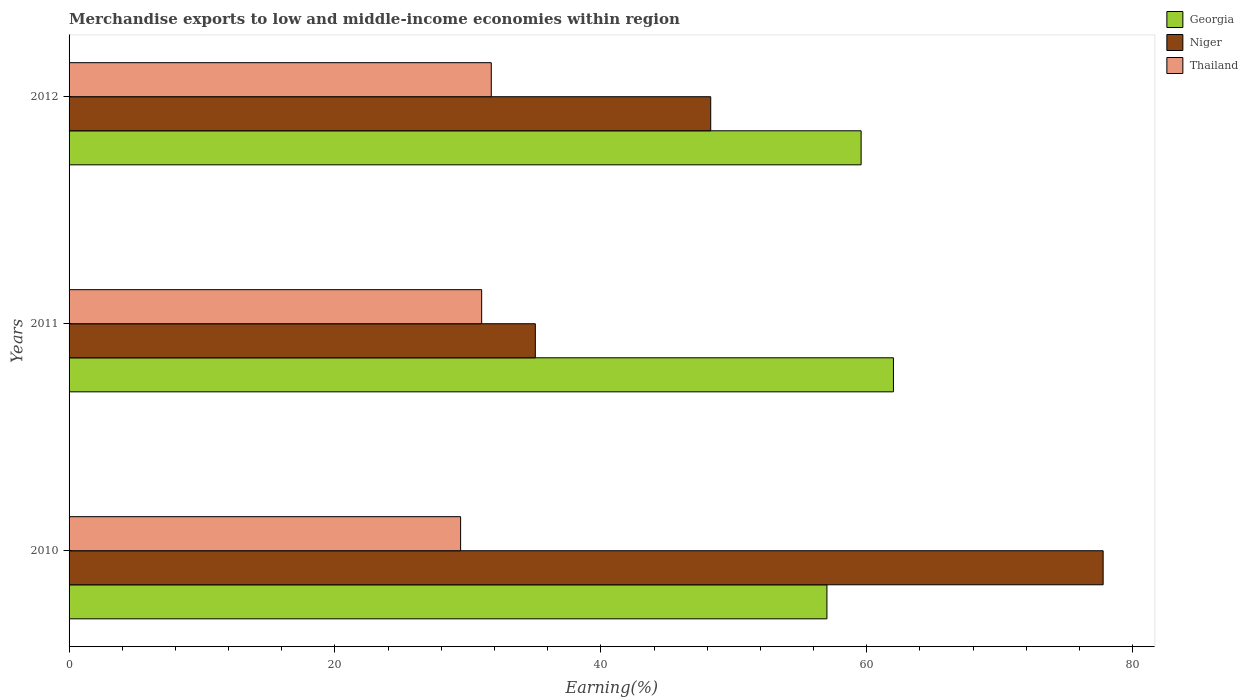Are the number of bars on each tick of the Y-axis equal?
Offer a very short reply. Yes. How many bars are there on the 2nd tick from the bottom?
Your answer should be compact. 3. What is the percentage of amount earned from merchandise exports in Thailand in 2012?
Keep it short and to the point. 31.76. Across all years, what is the maximum percentage of amount earned from merchandise exports in Niger?
Keep it short and to the point. 77.78. Across all years, what is the minimum percentage of amount earned from merchandise exports in Niger?
Provide a succinct answer. 35.07. In which year was the percentage of amount earned from merchandise exports in Thailand maximum?
Provide a succinct answer. 2012. In which year was the percentage of amount earned from merchandise exports in Georgia minimum?
Offer a very short reply. 2010. What is the total percentage of amount earned from merchandise exports in Niger in the graph?
Provide a short and direct response. 161.1. What is the difference between the percentage of amount earned from merchandise exports in Georgia in 2010 and that in 2011?
Your response must be concise. -5. What is the difference between the percentage of amount earned from merchandise exports in Georgia in 2011 and the percentage of amount earned from merchandise exports in Niger in 2012?
Provide a succinct answer. 13.74. What is the average percentage of amount earned from merchandise exports in Georgia per year?
Provide a succinct answer. 59.53. In the year 2011, what is the difference between the percentage of amount earned from merchandise exports in Georgia and percentage of amount earned from merchandise exports in Niger?
Provide a succinct answer. 26.93. What is the ratio of the percentage of amount earned from merchandise exports in Niger in 2010 to that in 2011?
Make the answer very short. 2.22. Is the percentage of amount earned from merchandise exports in Thailand in 2010 less than that in 2011?
Keep it short and to the point. Yes. What is the difference between the highest and the second highest percentage of amount earned from merchandise exports in Thailand?
Ensure brevity in your answer.  0.72. What is the difference between the highest and the lowest percentage of amount earned from merchandise exports in Niger?
Give a very brief answer. 42.71. In how many years, is the percentage of amount earned from merchandise exports in Thailand greater than the average percentage of amount earned from merchandise exports in Thailand taken over all years?
Give a very brief answer. 2. Is the sum of the percentage of amount earned from merchandise exports in Thailand in 2011 and 2012 greater than the maximum percentage of amount earned from merchandise exports in Georgia across all years?
Provide a succinct answer. Yes. What does the 2nd bar from the top in 2011 represents?
Your answer should be very brief. Niger. What does the 1st bar from the bottom in 2010 represents?
Your response must be concise. Georgia. Is it the case that in every year, the sum of the percentage of amount earned from merchandise exports in Niger and percentage of amount earned from merchandise exports in Georgia is greater than the percentage of amount earned from merchandise exports in Thailand?
Your response must be concise. Yes. How many bars are there?
Offer a terse response. 9. How many years are there in the graph?
Provide a succinct answer. 3. What is the difference between two consecutive major ticks on the X-axis?
Provide a short and direct response. 20. Are the values on the major ticks of X-axis written in scientific E-notation?
Offer a very short reply. No. How many legend labels are there?
Provide a short and direct response. 3. What is the title of the graph?
Ensure brevity in your answer.  Merchandise exports to low and middle-income economies within region. What is the label or title of the X-axis?
Keep it short and to the point. Earning(%). What is the label or title of the Y-axis?
Provide a short and direct response. Years. What is the Earning(%) in Georgia in 2010?
Make the answer very short. 57. What is the Earning(%) in Niger in 2010?
Provide a short and direct response. 77.78. What is the Earning(%) in Thailand in 2010?
Offer a very short reply. 29.45. What is the Earning(%) in Georgia in 2011?
Your answer should be compact. 62. What is the Earning(%) in Niger in 2011?
Offer a terse response. 35.07. What is the Earning(%) of Thailand in 2011?
Keep it short and to the point. 31.03. What is the Earning(%) of Georgia in 2012?
Make the answer very short. 59.57. What is the Earning(%) in Niger in 2012?
Your response must be concise. 48.26. What is the Earning(%) in Thailand in 2012?
Provide a short and direct response. 31.76. Across all years, what is the maximum Earning(%) of Georgia?
Keep it short and to the point. 62. Across all years, what is the maximum Earning(%) of Niger?
Provide a succinct answer. 77.78. Across all years, what is the maximum Earning(%) in Thailand?
Provide a succinct answer. 31.76. Across all years, what is the minimum Earning(%) in Georgia?
Your answer should be very brief. 57. Across all years, what is the minimum Earning(%) in Niger?
Provide a short and direct response. 35.07. Across all years, what is the minimum Earning(%) of Thailand?
Provide a succinct answer. 29.45. What is the total Earning(%) of Georgia in the graph?
Provide a short and direct response. 178.58. What is the total Earning(%) in Niger in the graph?
Provide a short and direct response. 161.1. What is the total Earning(%) in Thailand in the graph?
Your response must be concise. 92.24. What is the difference between the Earning(%) in Georgia in 2010 and that in 2011?
Keep it short and to the point. -5. What is the difference between the Earning(%) in Niger in 2010 and that in 2011?
Offer a very short reply. 42.71. What is the difference between the Earning(%) in Thailand in 2010 and that in 2011?
Keep it short and to the point. -1.58. What is the difference between the Earning(%) in Georgia in 2010 and that in 2012?
Give a very brief answer. -2.57. What is the difference between the Earning(%) in Niger in 2010 and that in 2012?
Offer a terse response. 29.52. What is the difference between the Earning(%) of Thailand in 2010 and that in 2012?
Offer a very short reply. -2.31. What is the difference between the Earning(%) in Georgia in 2011 and that in 2012?
Give a very brief answer. 2.43. What is the difference between the Earning(%) of Niger in 2011 and that in 2012?
Your response must be concise. -13.19. What is the difference between the Earning(%) of Thailand in 2011 and that in 2012?
Your response must be concise. -0.72. What is the difference between the Earning(%) of Georgia in 2010 and the Earning(%) of Niger in 2011?
Offer a very short reply. 21.93. What is the difference between the Earning(%) of Georgia in 2010 and the Earning(%) of Thailand in 2011?
Your answer should be very brief. 25.97. What is the difference between the Earning(%) in Niger in 2010 and the Earning(%) in Thailand in 2011?
Keep it short and to the point. 46.74. What is the difference between the Earning(%) in Georgia in 2010 and the Earning(%) in Niger in 2012?
Keep it short and to the point. 8.74. What is the difference between the Earning(%) of Georgia in 2010 and the Earning(%) of Thailand in 2012?
Offer a terse response. 25.25. What is the difference between the Earning(%) of Niger in 2010 and the Earning(%) of Thailand in 2012?
Your answer should be very brief. 46.02. What is the difference between the Earning(%) of Georgia in 2011 and the Earning(%) of Niger in 2012?
Ensure brevity in your answer.  13.74. What is the difference between the Earning(%) of Georgia in 2011 and the Earning(%) of Thailand in 2012?
Keep it short and to the point. 30.25. What is the difference between the Earning(%) of Niger in 2011 and the Earning(%) of Thailand in 2012?
Make the answer very short. 3.31. What is the average Earning(%) in Georgia per year?
Provide a short and direct response. 59.53. What is the average Earning(%) in Niger per year?
Give a very brief answer. 53.7. What is the average Earning(%) in Thailand per year?
Your response must be concise. 30.75. In the year 2010, what is the difference between the Earning(%) in Georgia and Earning(%) in Niger?
Give a very brief answer. -20.77. In the year 2010, what is the difference between the Earning(%) of Georgia and Earning(%) of Thailand?
Make the answer very short. 27.55. In the year 2010, what is the difference between the Earning(%) in Niger and Earning(%) in Thailand?
Your answer should be compact. 48.33. In the year 2011, what is the difference between the Earning(%) in Georgia and Earning(%) in Niger?
Make the answer very short. 26.93. In the year 2011, what is the difference between the Earning(%) of Georgia and Earning(%) of Thailand?
Your answer should be very brief. 30.97. In the year 2011, what is the difference between the Earning(%) of Niger and Earning(%) of Thailand?
Provide a succinct answer. 4.04. In the year 2012, what is the difference between the Earning(%) in Georgia and Earning(%) in Niger?
Give a very brief answer. 11.31. In the year 2012, what is the difference between the Earning(%) in Georgia and Earning(%) in Thailand?
Your answer should be compact. 27.82. In the year 2012, what is the difference between the Earning(%) of Niger and Earning(%) of Thailand?
Make the answer very short. 16.5. What is the ratio of the Earning(%) of Georgia in 2010 to that in 2011?
Ensure brevity in your answer.  0.92. What is the ratio of the Earning(%) of Niger in 2010 to that in 2011?
Your answer should be compact. 2.22. What is the ratio of the Earning(%) in Thailand in 2010 to that in 2011?
Make the answer very short. 0.95. What is the ratio of the Earning(%) in Georgia in 2010 to that in 2012?
Your answer should be very brief. 0.96. What is the ratio of the Earning(%) in Niger in 2010 to that in 2012?
Provide a short and direct response. 1.61. What is the ratio of the Earning(%) in Thailand in 2010 to that in 2012?
Provide a short and direct response. 0.93. What is the ratio of the Earning(%) in Georgia in 2011 to that in 2012?
Provide a succinct answer. 1.04. What is the ratio of the Earning(%) of Niger in 2011 to that in 2012?
Your answer should be compact. 0.73. What is the ratio of the Earning(%) in Thailand in 2011 to that in 2012?
Make the answer very short. 0.98. What is the difference between the highest and the second highest Earning(%) of Georgia?
Your answer should be compact. 2.43. What is the difference between the highest and the second highest Earning(%) in Niger?
Give a very brief answer. 29.52. What is the difference between the highest and the second highest Earning(%) of Thailand?
Your response must be concise. 0.72. What is the difference between the highest and the lowest Earning(%) of Georgia?
Your answer should be compact. 5. What is the difference between the highest and the lowest Earning(%) of Niger?
Make the answer very short. 42.71. What is the difference between the highest and the lowest Earning(%) of Thailand?
Your response must be concise. 2.31. 